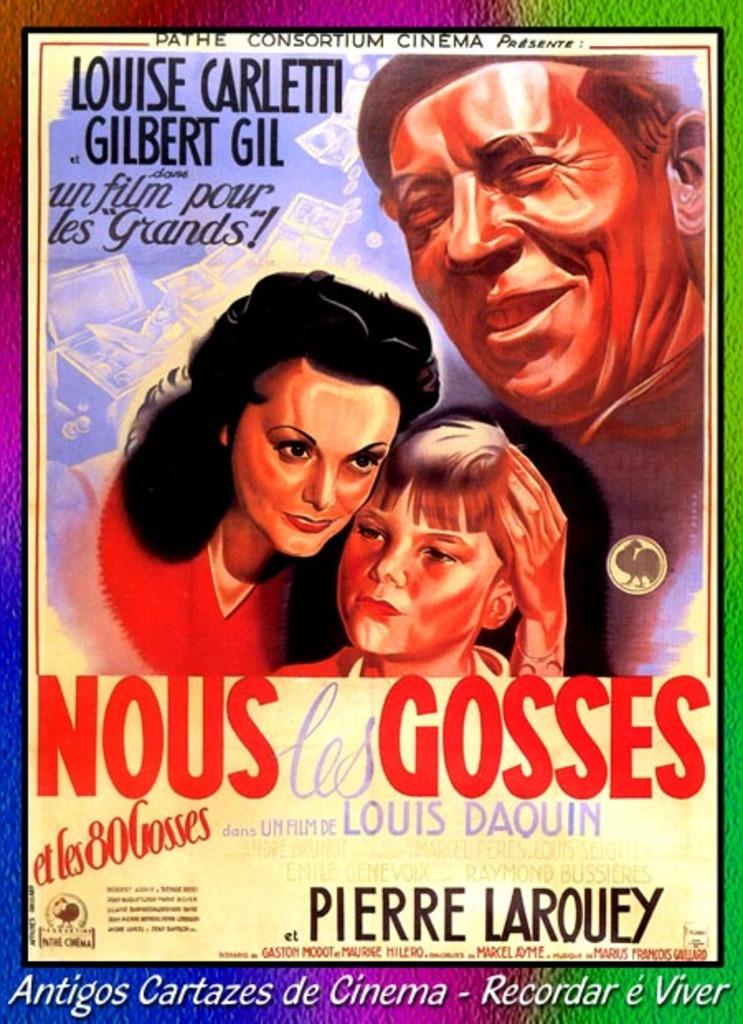<image>
Provide a brief description of the given image. Pathe Consortium Cinema presents Nouse Les Gosses a film by Pierre Larouey 